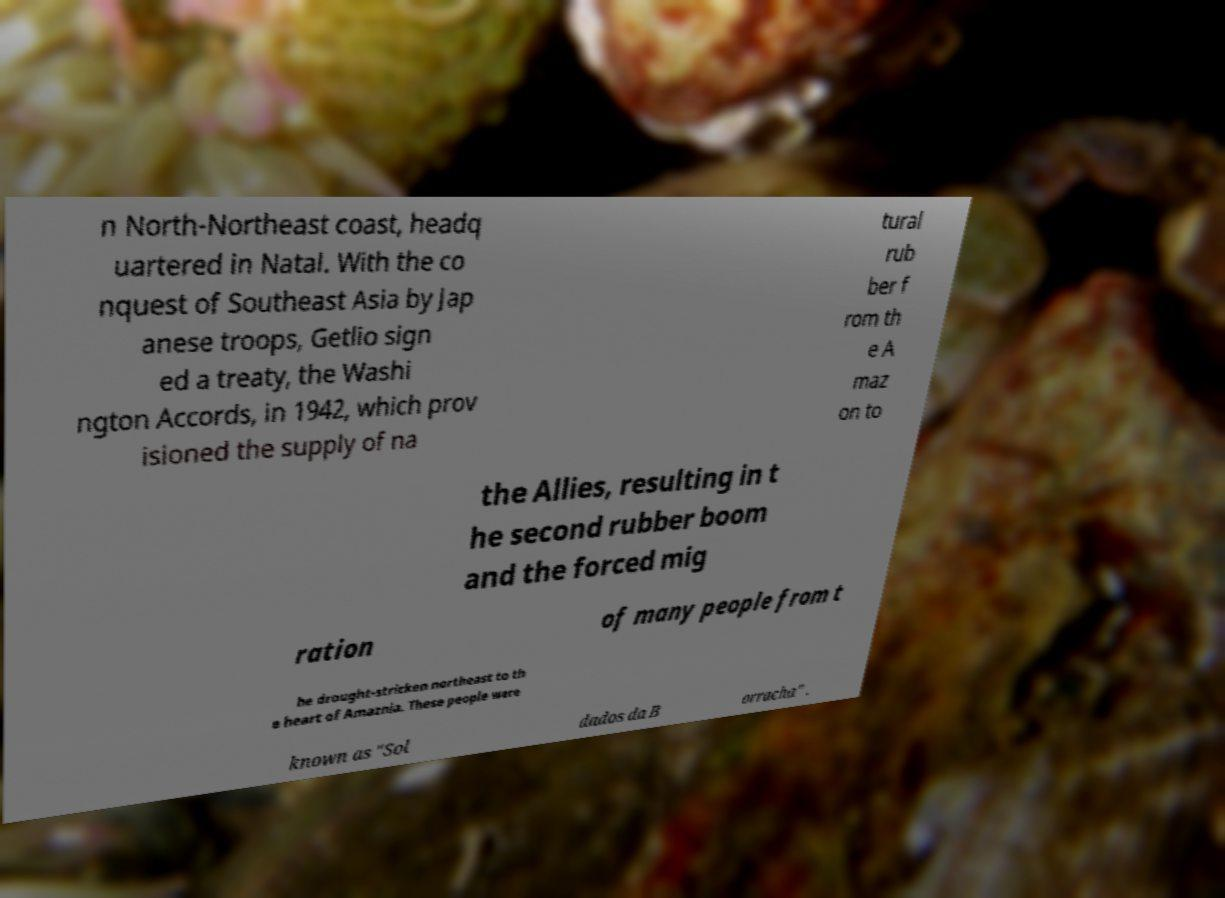What messages or text are displayed in this image? I need them in a readable, typed format. n North-Northeast coast, headq uartered in Natal. With the co nquest of Southeast Asia by Jap anese troops, Getlio sign ed a treaty, the Washi ngton Accords, in 1942, which prov isioned the supply of na tural rub ber f rom th e A maz on to the Allies, resulting in t he second rubber boom and the forced mig ration of many people from t he drought-stricken northeast to th e heart of Amaznia. These people were known as "Sol dados da B orracha" . 